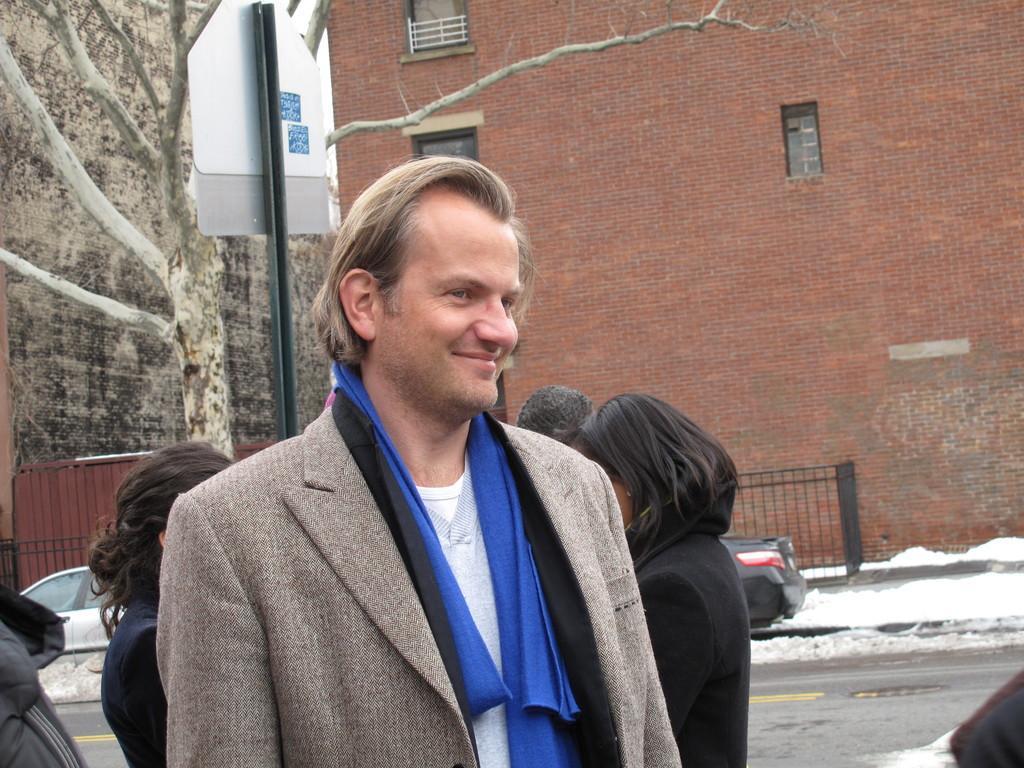In one or two sentences, can you explain what this image depicts? In this picture we can see a man wore a blazer and smiling and at the back of them we can see some people standing, cars on the road, snow, fence, board attached to a pole and in the background we can see windows, walls. 